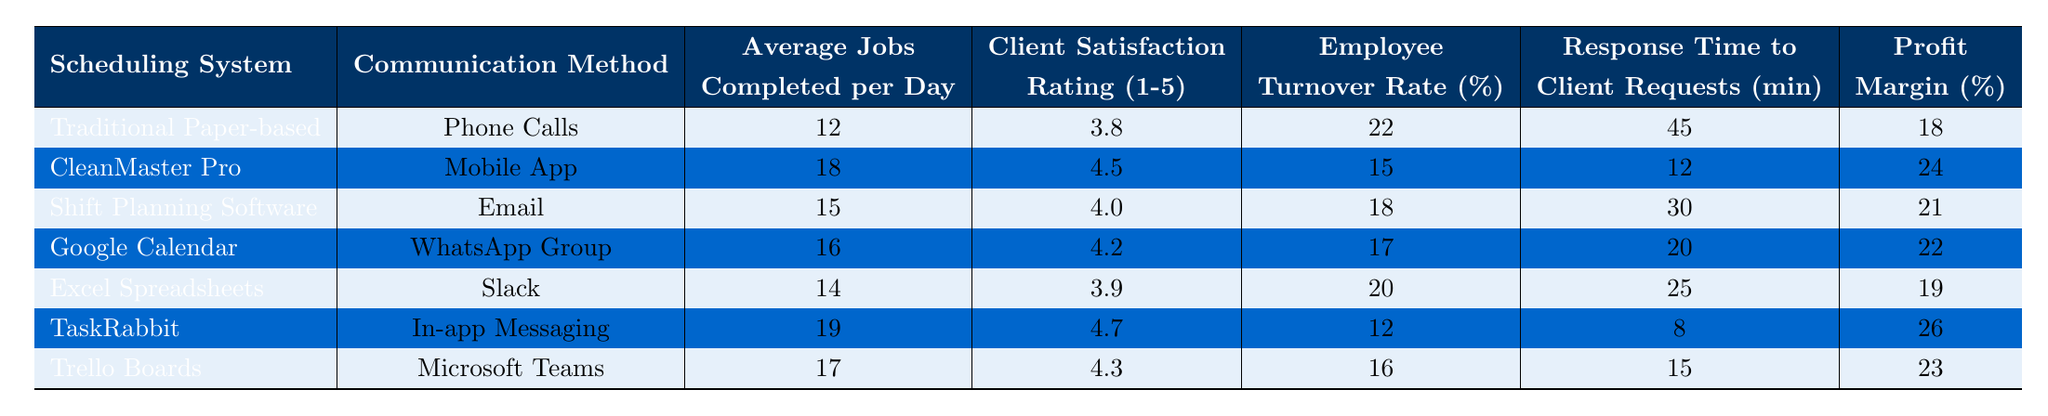What is the average number of jobs completed per day using the CleanMaster Pro system? According to the table, the average jobs completed per day with the CleanMaster Pro system is 18.
Answer: 18 How many jobs do teams complete per day using the traditional paper-based system? The traditional paper-based system has an average of 12 jobs completed per day, as shown in the table.
Answer: 12 Which scheduling system has the highest client satisfaction rating? The scheduling system with the highest client satisfaction rating is TaskRabbit, with a rating of 4.7.
Answer: TaskRabbit What is the employee turnover rate for teams using Excel Spreadsheets? The employee turnover rate for teams using Excel Spreadsheets is 20%, as detailed in the table.
Answer: 20% Can teams using Google Calendar complete more jobs per day than those using Shift Planning Software? Yes, teams using Google Calendar complete 16 jobs per day, which is more than the 15 jobs completed by teams using Shift Planning Software.
Answer: Yes What is the profit margin for teams using the traditional paper-based scheduling system? The profit margin for the traditional paper-based scheduling system is 18%, as seen in the table.
Answer: 18% Which scheduling system has the lowest response time to client requests? The scheduling system with the lowest response time to client requests is TaskRabbit, taking only 8 minutes.
Answer: TaskRabbit If the average number of jobs completed per day with CleanMaster Pro is 18 and the average for Excel Spreadsheets is 14, what is the difference in jobs completed between these two systems? The difference in average jobs completed per day is calculated as 18 (CleanMaster Pro) - 14 (Excel Spreadsheets) = 4.
Answer: 4 What is the total client satisfaction rating of both Trello Boards and Google Calendar? The total client satisfaction rating is computed by adding both ratings: 4.3 (Trello Boards) + 4.2 (Google Calendar) = 8.5.
Answer: 8.5 Is the average response time for client requests shorter for TaskRabbit compared to the Shift Planning Software? Yes, TaskRabbit's average response time is 8 minutes, which is shorter than the 30 minutes for Shift Planning Software.
Answer: Yes 